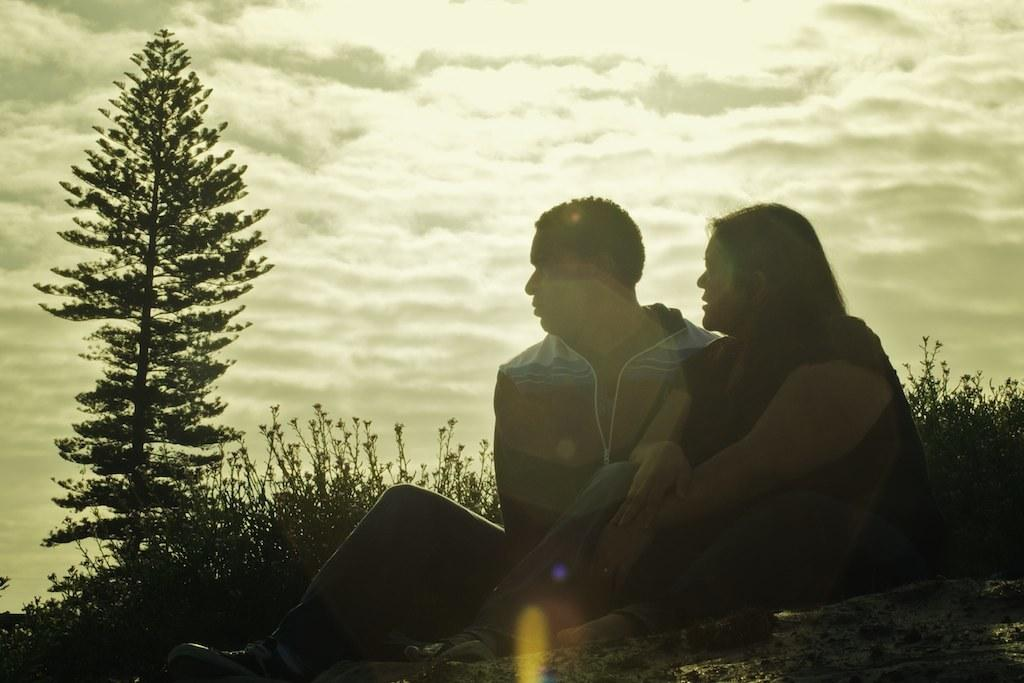How many people are in the image? There is a man and a woman in the image. What are the man and woman doing in the image? Both the man and woman are sitting on the ground. What can be seen in the background of the image? There are plants and a tree in the background of the image. What is visible at the top of the image? The sky is visible at the top of the image. What type of clam can be seen crawling on the ground in the image? There are no clams present in the image; the man and woman are sitting on the ground. What color is the grass in the image? There is no grass visible in the image; only plants and a tree are present in the background. 